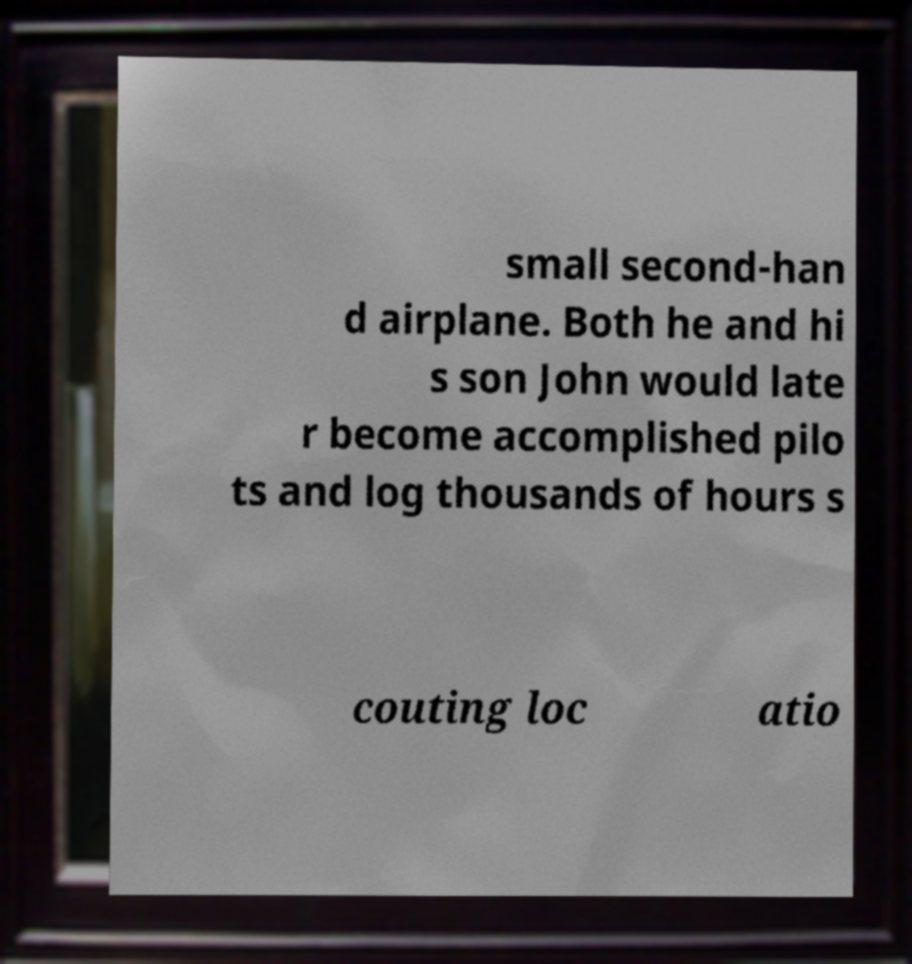There's text embedded in this image that I need extracted. Can you transcribe it verbatim? small second-han d airplane. Both he and hi s son John would late r become accomplished pilo ts and log thousands of hours s couting loc atio 